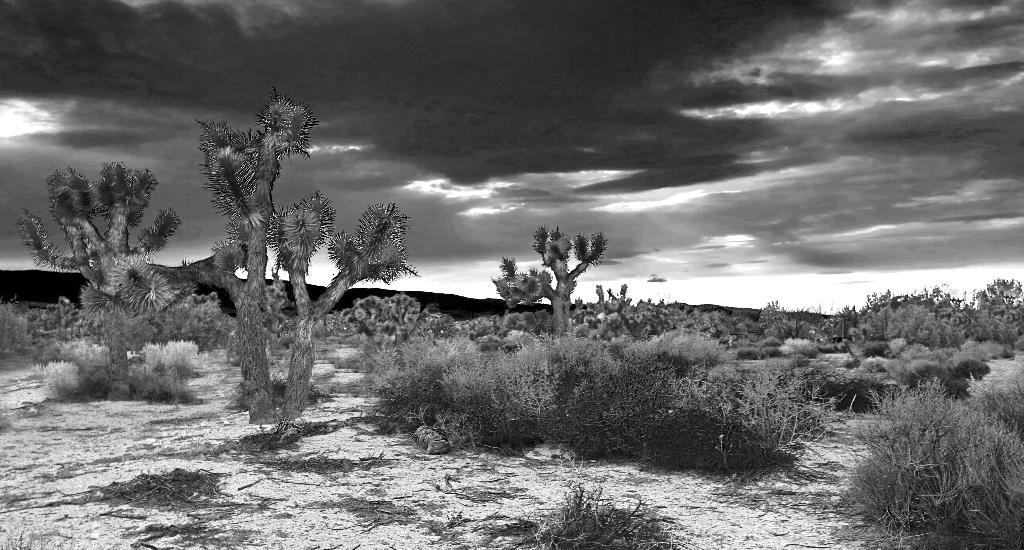What type of vegetation can be seen in the image? There are many trees and plants on the ground in the image. What can be seen in the sky in the image? There are clouds visible in the image, and the sky is also visible. Can you describe the ground in the image? The ground in the image is covered with plants. How does the image start to sort the plants by color? The image does not sort the plants by color; it simply shows the plants as they are. 